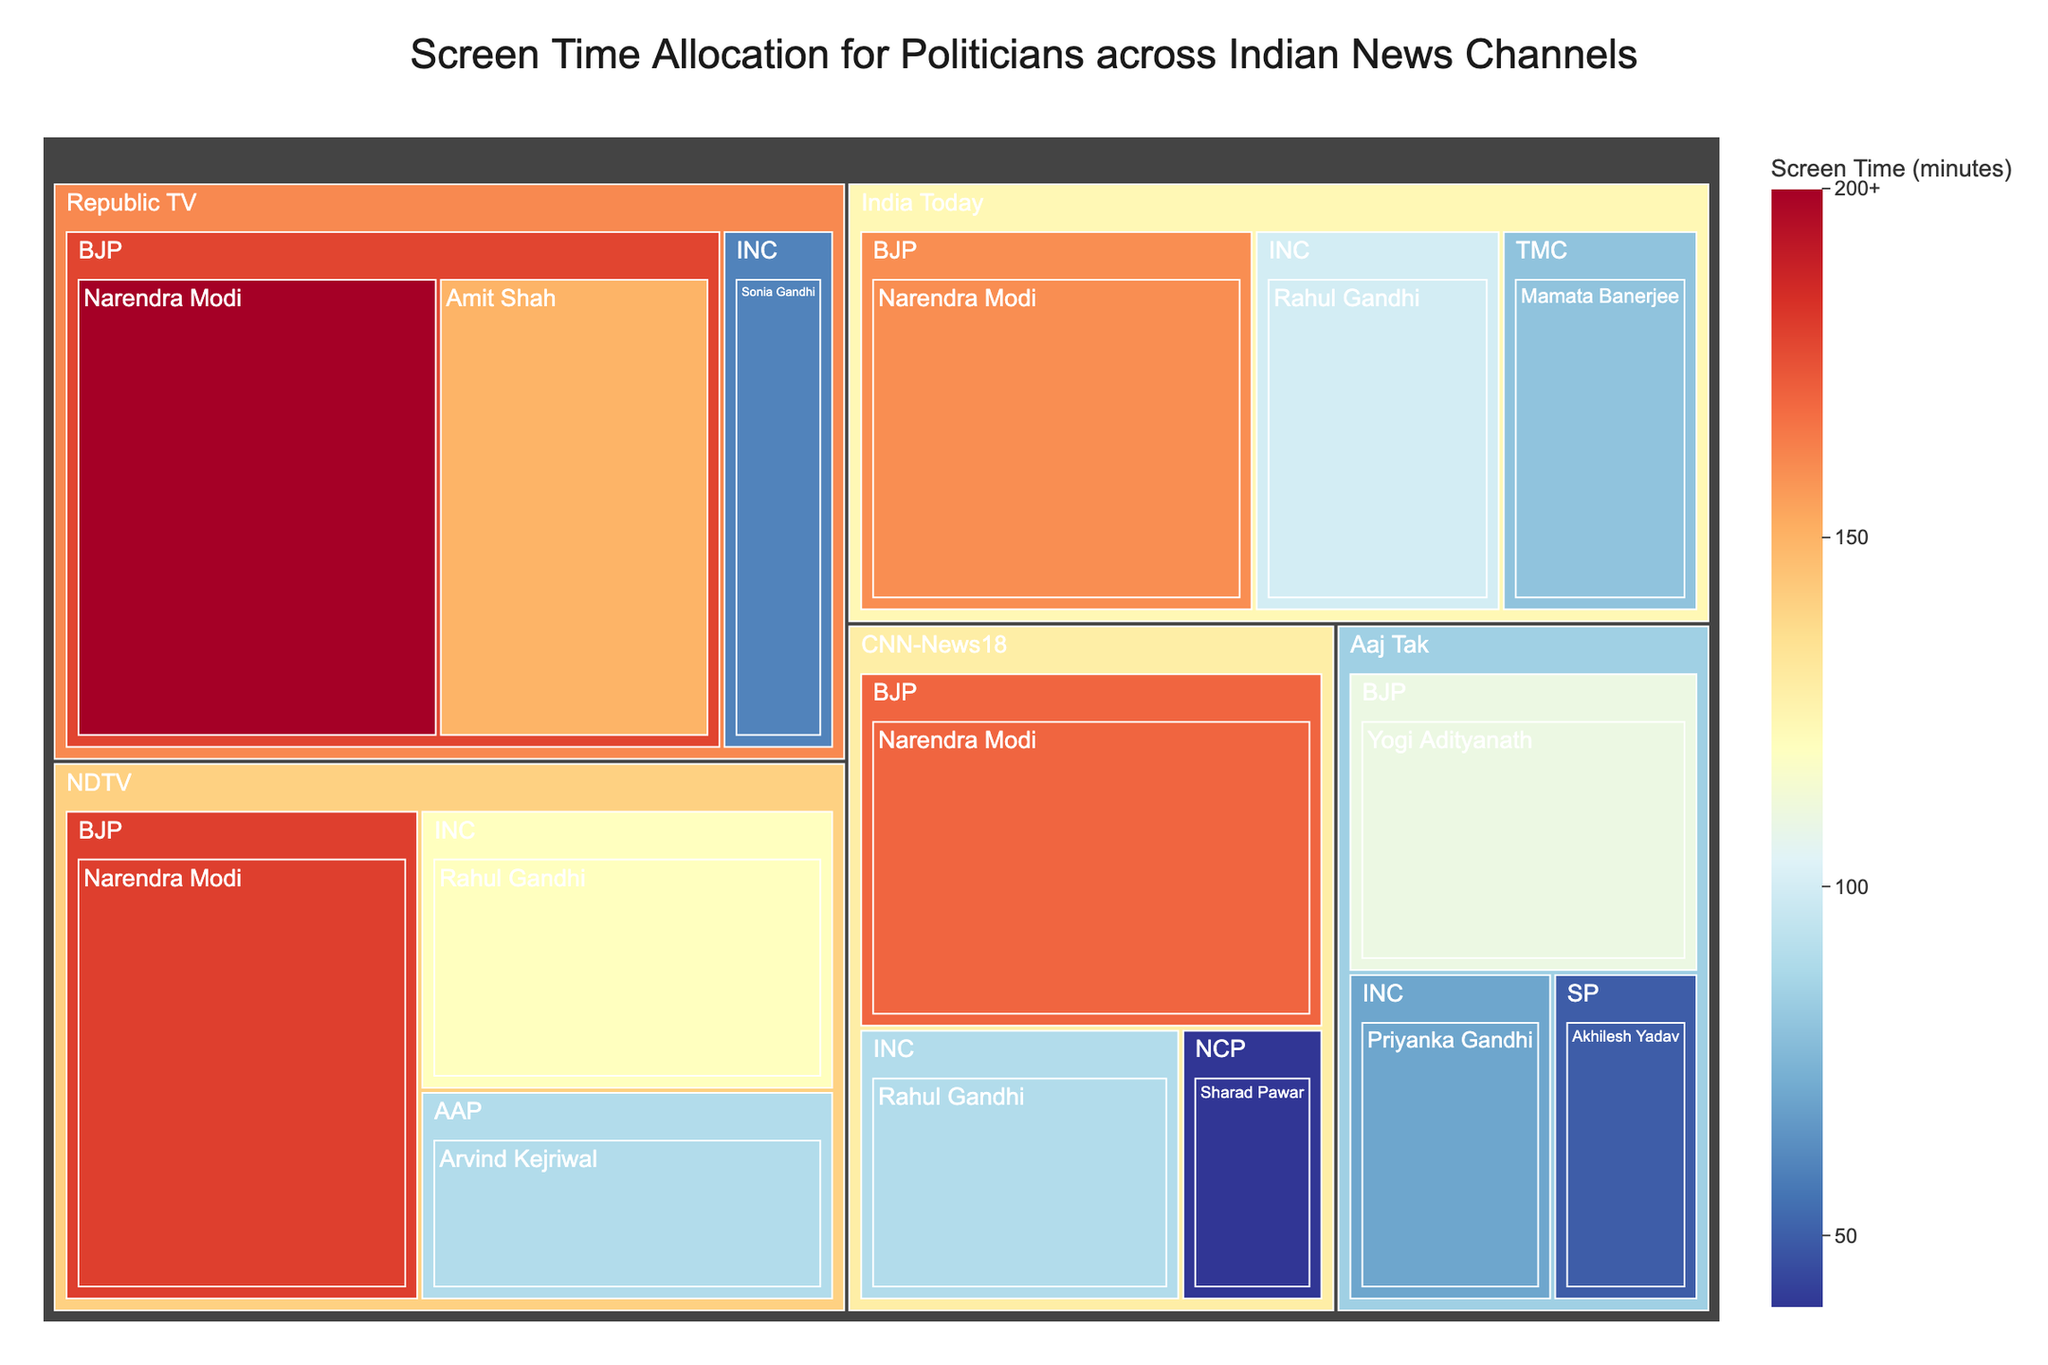What's the title of the treemap? The title is usually displayed at the top of a plot and summarizes what the plot represents. In this treemap, it is mentioned in the code as 'Screen Time Allocation for Politicians across Indian News Channels'.
Answer: Screen Time Allocation for Politicians across Indian News Channels Which politician from the BJP has the highest screen time on Republic TV? To answer this, look for the BJP and Republic TV segments. Within the Republic TV segment, identify the BJP politician with the largest individual screen time.
Answer: Narendra Modi How much screen time does Rahul Gandhi have across all news channels? Sum the values of screen time for Rahul Gandhi from all channels. His screen time is 120 (NDTV) + 100 (India Today) + 90 (CNN-News18).
Answer: 310 minutes Which news channel has the highest cumulative screen time for BJP politicians? Sum the screen times of all BJP politicians for each channel and compare them. For NDTV (180), Republic TV (350), India Today (160), Aaj Tak (110), and CNN-News 18 (170). The highest is Republic TV with 350 minutes.
Answer: Republic TV Compare Narendra Modi's screen time on NDTV and CNN-News18. Which channel gives him more time? Look at the segments representing Narendra Modi on NDTV and CNN-News18. Compare the screen times: 180 minutes (NDTV) vs. 170 minutes (CNN-News18).
Answer: NDTV Which political party has the most diverse representation of politicians across different news channels? Look at the number of distinct politicians represented for each political party across all channels. BJP has the most politicians listed: Narendra Modi, Amit Shah, Yogi Adityanath.
Answer: BJP What is the combined screen time for all politicians represented on India Today? Sum the screen times for all politicians on India Today: Narendra Modi (160), Rahul Gandhi (100), Mamata Banerjee (80).
Answer: 340 minutes Which politician has the least screen time overall, and on which channel? Scan through all the segments to find the politician with the lowest screen time. Sharad Pawar has 40 minutes on CNN-News18.
Answer: Sharad Pawar, CNN-News18 Which news channel provides the least screen time to INC politicians? Sum the screen time of INC politicians for each channel. Compare these sums: NDTV (120), Republic TV (60), India Today (100), Aaj Tak (70), CNN-News18 (90). The least is Republic TV with 60 minutes.
Answer: Republic TV 